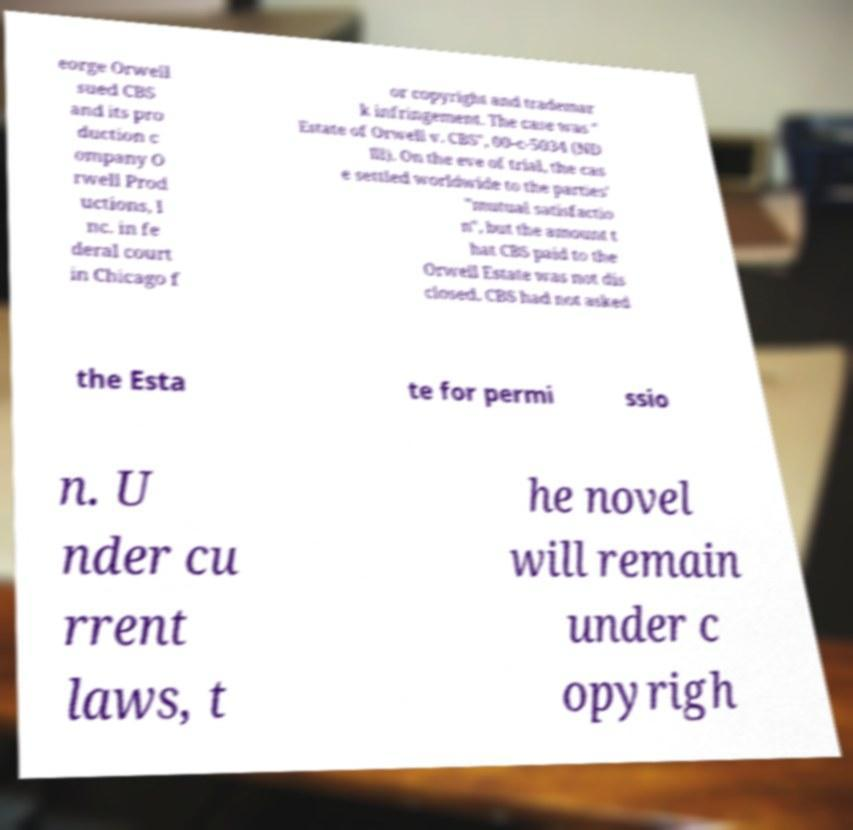Please read and relay the text visible in this image. What does it say? eorge Orwell sued CBS and its pro duction c ompany O rwell Prod uctions, I nc. in fe deral court in Chicago f or copyright and trademar k infringement. The case was " Estate of Orwell v. CBS", 00-c-5034 (ND Ill). On the eve of trial, the cas e settled worldwide to the parties' "mutual satisfactio n", but the amount t hat CBS paid to the Orwell Estate was not dis closed. CBS had not asked the Esta te for permi ssio n. U nder cu rrent laws, t he novel will remain under c opyrigh 